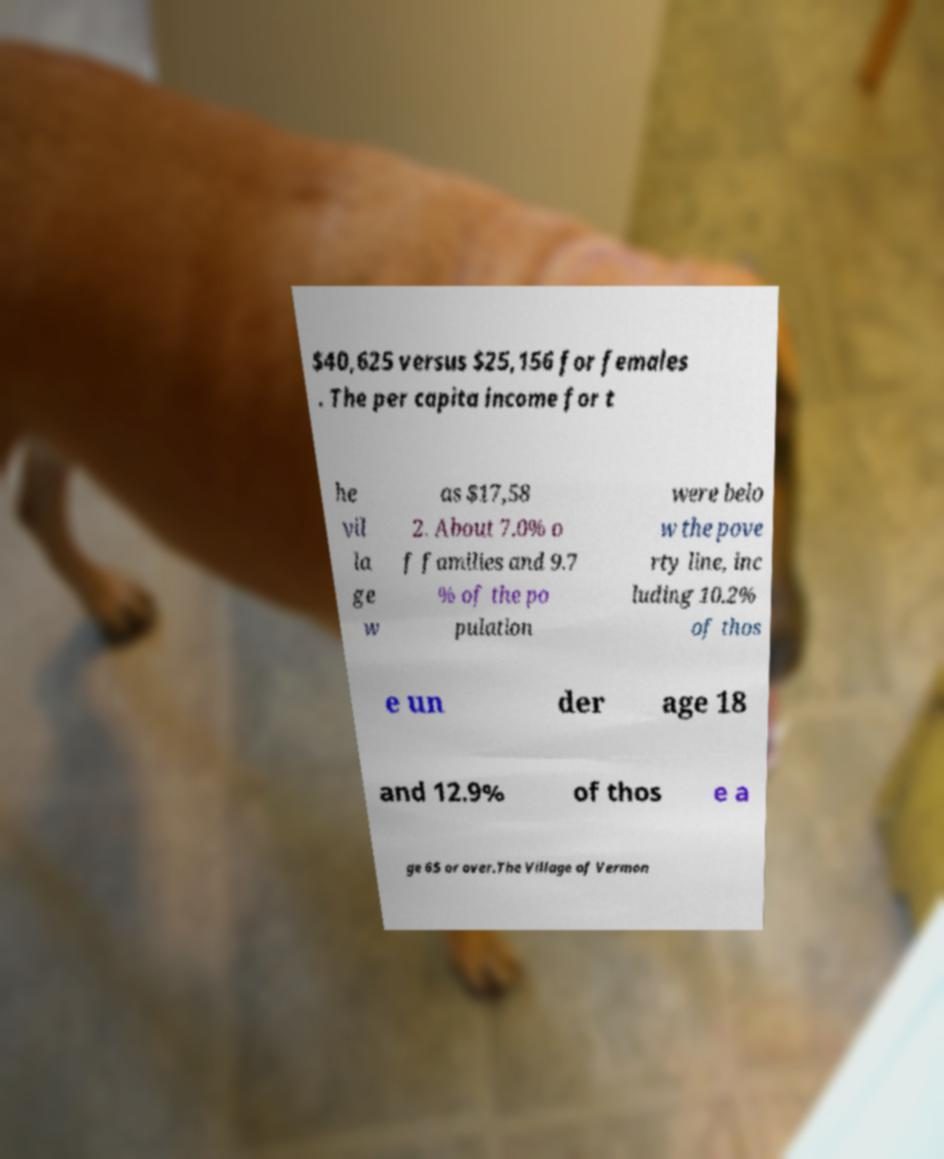What messages or text are displayed in this image? I need them in a readable, typed format. $40,625 versus $25,156 for females . The per capita income for t he vil la ge w as $17,58 2. About 7.0% o f families and 9.7 % of the po pulation were belo w the pove rty line, inc luding 10.2% of thos e un der age 18 and 12.9% of thos e a ge 65 or over.The Village of Vermon 